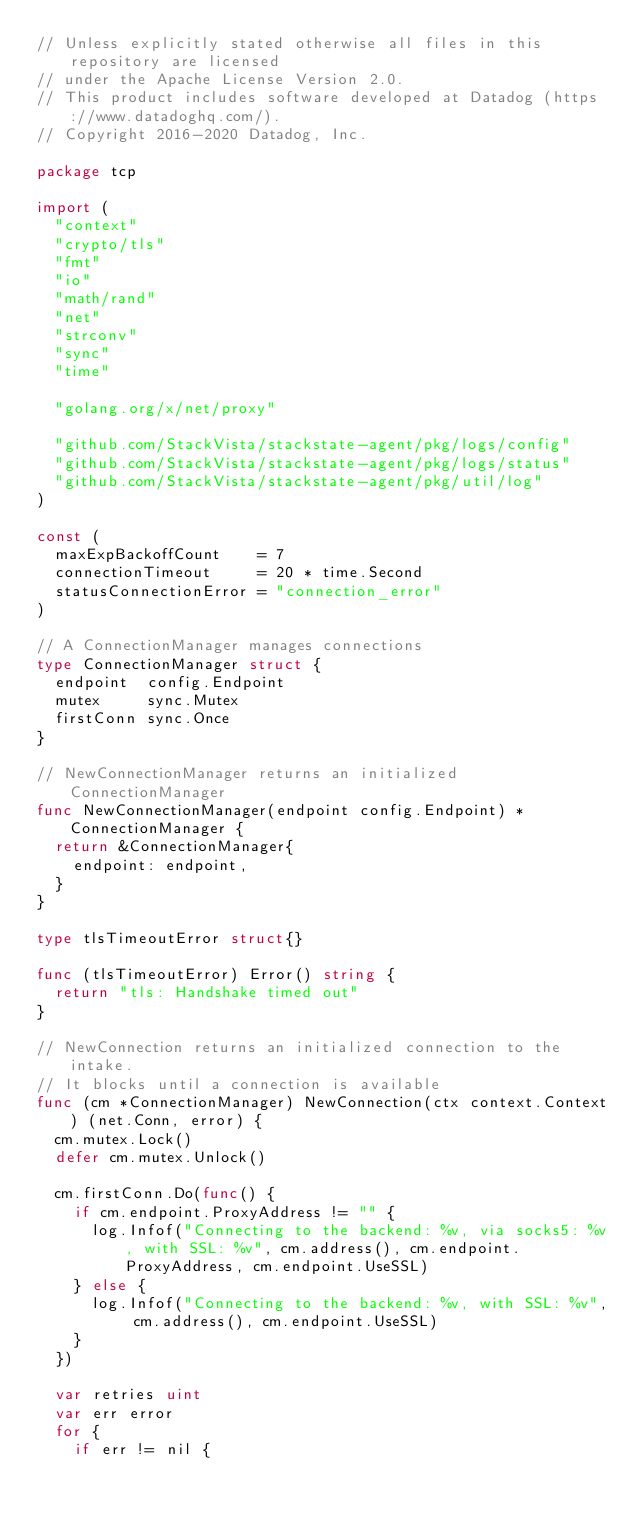Convert code to text. <code><loc_0><loc_0><loc_500><loc_500><_Go_>// Unless explicitly stated otherwise all files in this repository are licensed
// under the Apache License Version 2.0.
// This product includes software developed at Datadog (https://www.datadoghq.com/).
// Copyright 2016-2020 Datadog, Inc.

package tcp

import (
	"context"
	"crypto/tls"
	"fmt"
	"io"
	"math/rand"
	"net"
	"strconv"
	"sync"
	"time"

	"golang.org/x/net/proxy"

	"github.com/StackVista/stackstate-agent/pkg/logs/config"
	"github.com/StackVista/stackstate-agent/pkg/logs/status"
	"github.com/StackVista/stackstate-agent/pkg/util/log"
)

const (
	maxExpBackoffCount    = 7
	connectionTimeout     = 20 * time.Second
	statusConnectionError = "connection_error"
)

// A ConnectionManager manages connections
type ConnectionManager struct {
	endpoint  config.Endpoint
	mutex     sync.Mutex
	firstConn sync.Once
}

// NewConnectionManager returns an initialized ConnectionManager
func NewConnectionManager(endpoint config.Endpoint) *ConnectionManager {
	return &ConnectionManager{
		endpoint: endpoint,
	}
}

type tlsTimeoutError struct{}

func (tlsTimeoutError) Error() string {
	return "tls: Handshake timed out"
}

// NewConnection returns an initialized connection to the intake.
// It blocks until a connection is available
func (cm *ConnectionManager) NewConnection(ctx context.Context) (net.Conn, error) {
	cm.mutex.Lock()
	defer cm.mutex.Unlock()

	cm.firstConn.Do(func() {
		if cm.endpoint.ProxyAddress != "" {
			log.Infof("Connecting to the backend: %v, via socks5: %v, with SSL: %v", cm.address(), cm.endpoint.ProxyAddress, cm.endpoint.UseSSL)
		} else {
			log.Infof("Connecting to the backend: %v, with SSL: %v", cm.address(), cm.endpoint.UseSSL)
		}
	})

	var retries uint
	var err error
	for {
		if err != nil {</code> 